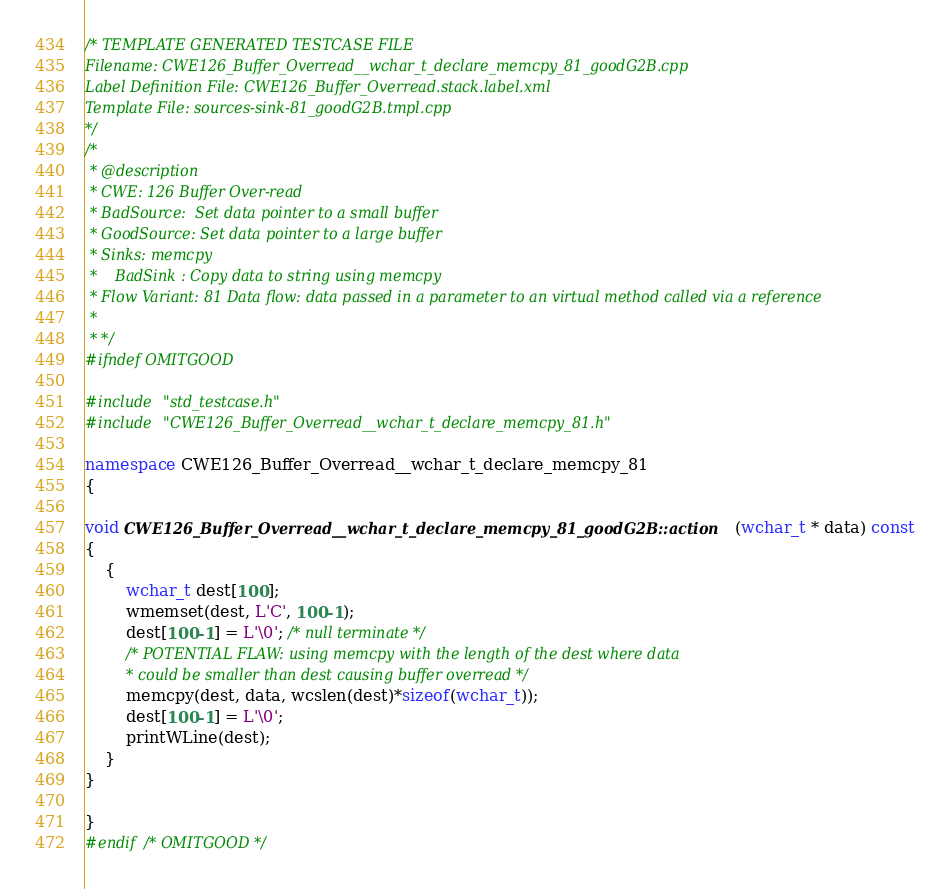<code> <loc_0><loc_0><loc_500><loc_500><_C++_>/* TEMPLATE GENERATED TESTCASE FILE
Filename: CWE126_Buffer_Overread__wchar_t_declare_memcpy_81_goodG2B.cpp
Label Definition File: CWE126_Buffer_Overread.stack.label.xml
Template File: sources-sink-81_goodG2B.tmpl.cpp
*/
/*
 * @description
 * CWE: 126 Buffer Over-read
 * BadSource:  Set data pointer to a small buffer
 * GoodSource: Set data pointer to a large buffer
 * Sinks: memcpy
 *    BadSink : Copy data to string using memcpy
 * Flow Variant: 81 Data flow: data passed in a parameter to an virtual method called via a reference
 *
 * */
#ifndef OMITGOOD

#include "std_testcase.h"
#include "CWE126_Buffer_Overread__wchar_t_declare_memcpy_81.h"

namespace CWE126_Buffer_Overread__wchar_t_declare_memcpy_81
{

void CWE126_Buffer_Overread__wchar_t_declare_memcpy_81_goodG2B::action(wchar_t * data) const
{
    {
        wchar_t dest[100];
        wmemset(dest, L'C', 100-1);
        dest[100-1] = L'\0'; /* null terminate */
        /* POTENTIAL FLAW: using memcpy with the length of the dest where data
         * could be smaller than dest causing buffer overread */
        memcpy(dest, data, wcslen(dest)*sizeof(wchar_t));
        dest[100-1] = L'\0';
        printWLine(dest);
    }
}

}
#endif /* OMITGOOD */
</code> 